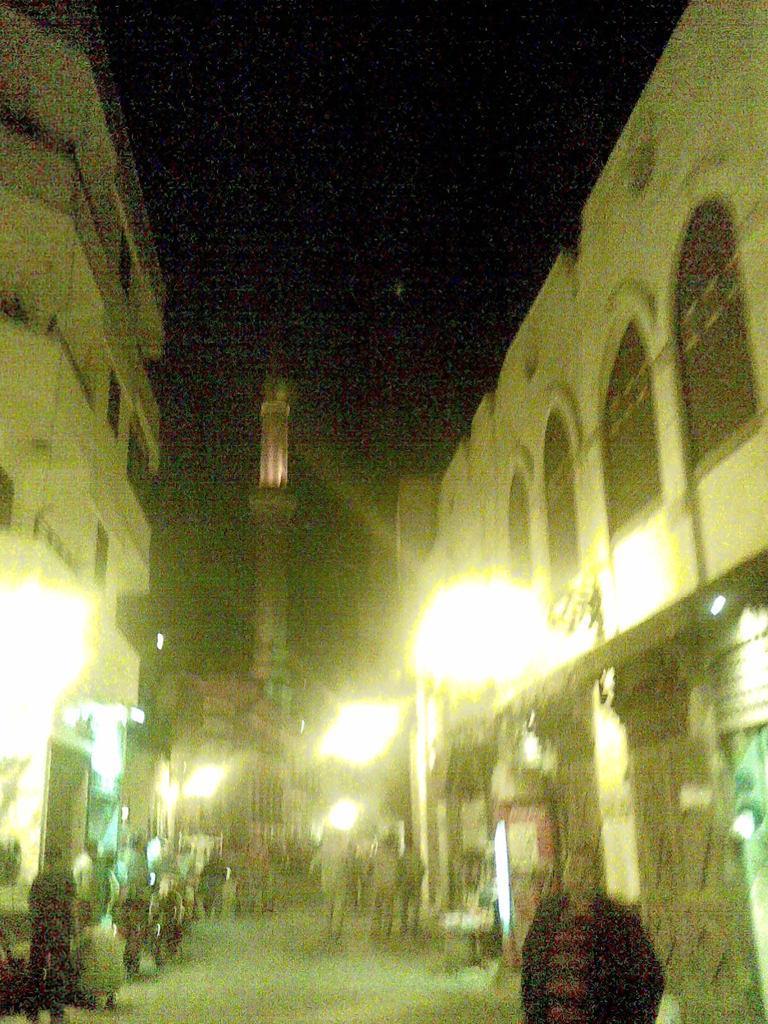In one or two sentences, can you explain what this image depicts? In this image there are group of people standing , buildings, lights, and in the background there is sky. 